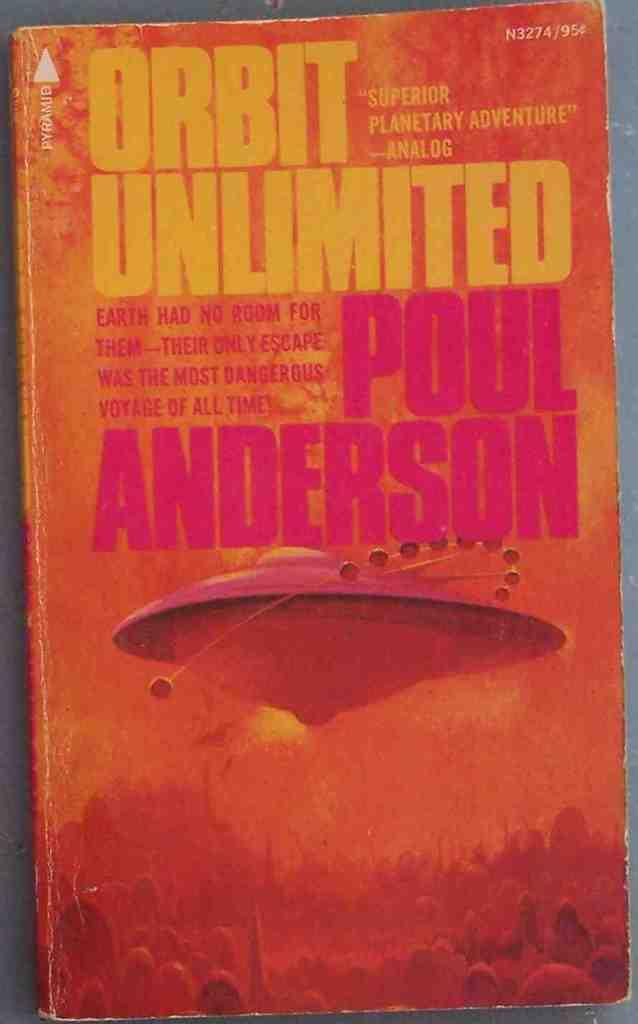<image>
Present a compact description of the photo's key features. Poul Anderson write Orbit Unlimited, which Analog says is a superior planetary adventure. 